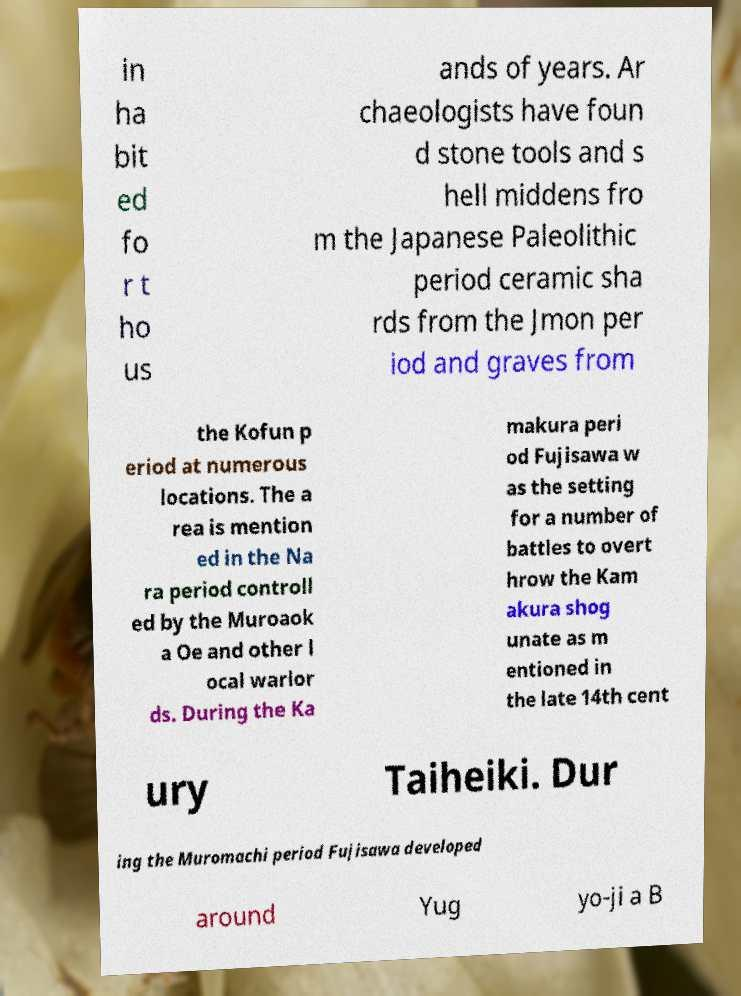What messages or text are displayed in this image? I need them in a readable, typed format. in ha bit ed fo r t ho us ands of years. Ar chaeologists have foun d stone tools and s hell middens fro m the Japanese Paleolithic period ceramic sha rds from the Jmon per iod and graves from the Kofun p eriod at numerous locations. The a rea is mention ed in the Na ra period controll ed by the Muroaok a Oe and other l ocal warlor ds. During the Ka makura peri od Fujisawa w as the setting for a number of battles to overt hrow the Kam akura shog unate as m entioned in the late 14th cent ury Taiheiki. Dur ing the Muromachi period Fujisawa developed around Yug yo-ji a B 